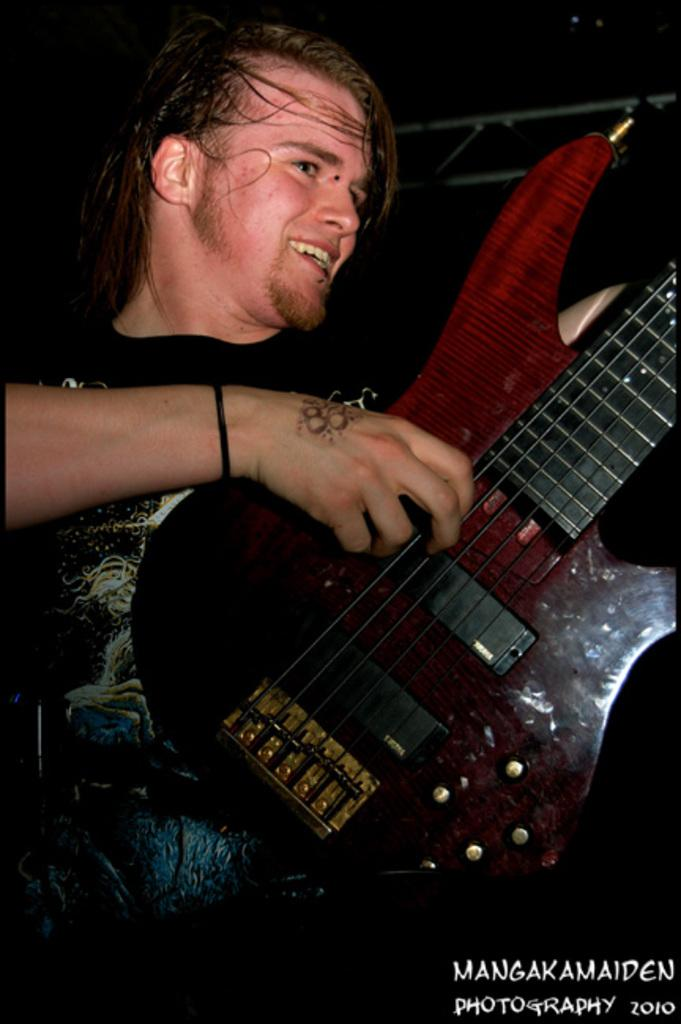What is the man in the image doing? The man is playing the guitar. What object is the man holding in the image? The man is holding a guitar. What type of net can be seen in the image? There is no net present in the image. Are there any snails visible in the image? There are no snails visible in the image. 